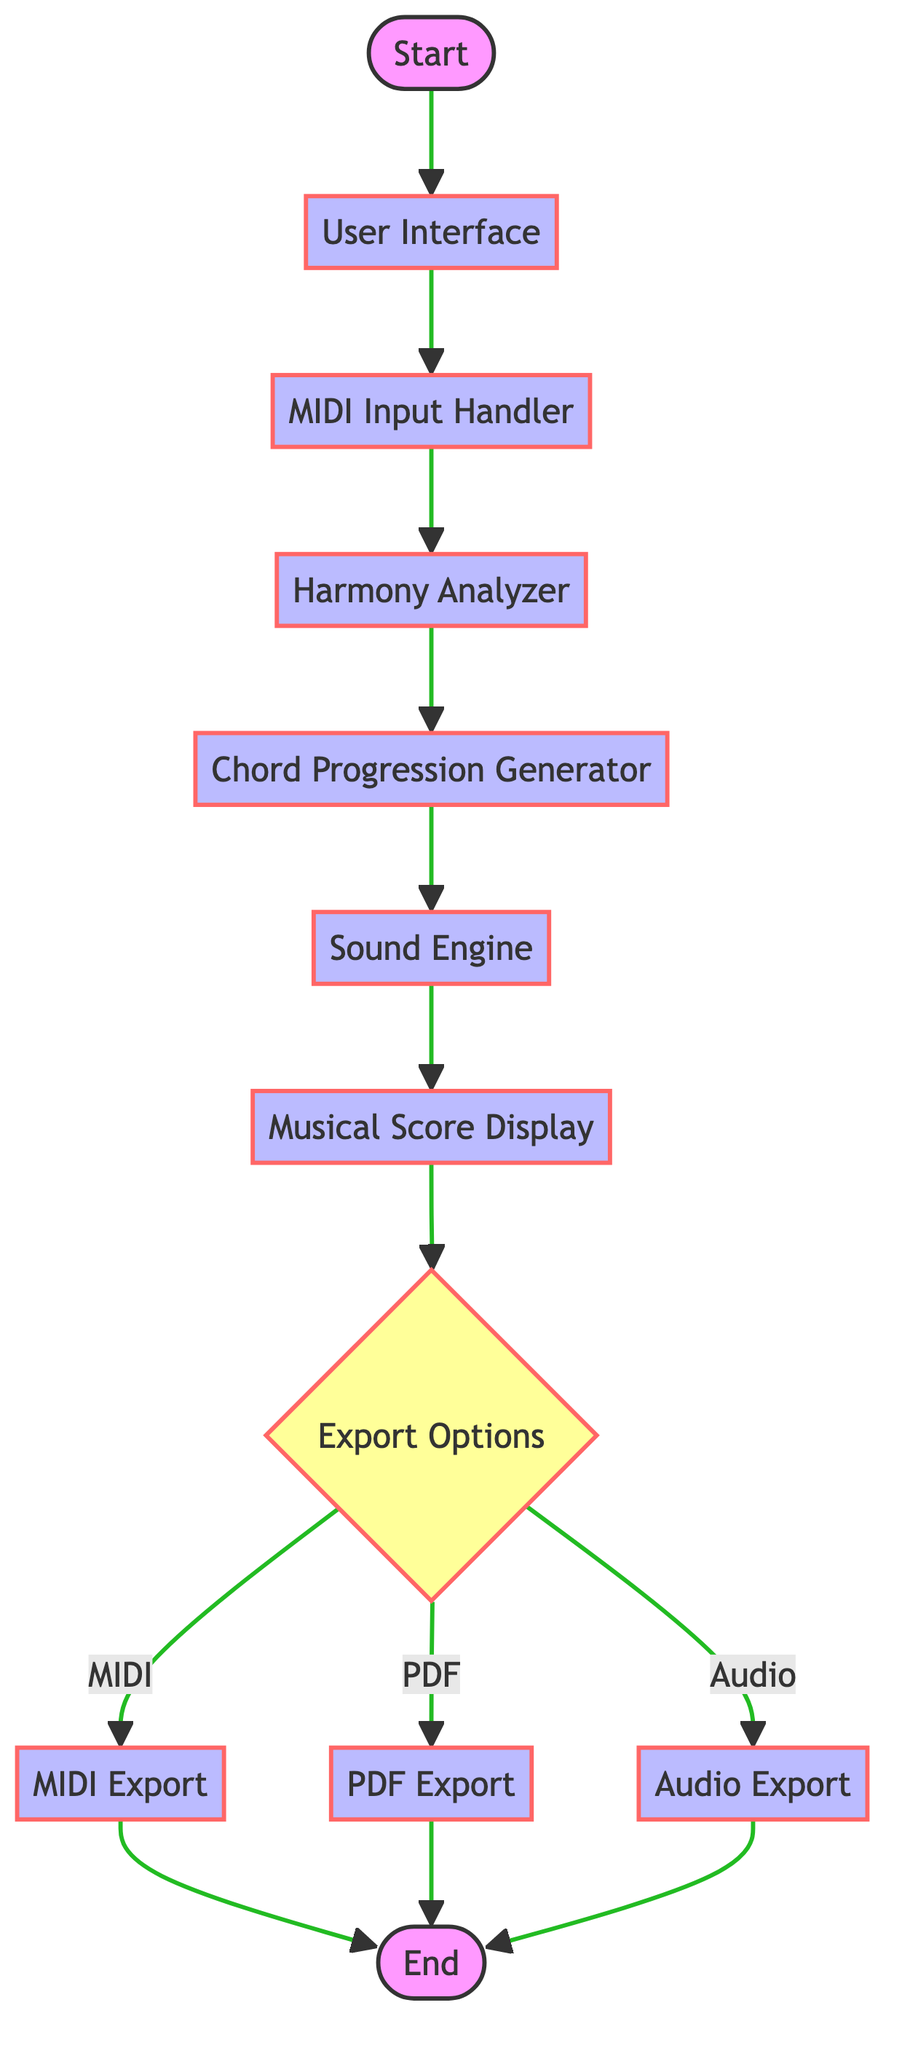What is the first node in the flowchart? The flowchart starts with the "Start" node, which is the initial point in the process.
Answer: Start How many process nodes are there in total? There are seven process nodes in the flowchart: User Interface, MIDI Input Handler, Harmony Analyzer, Chord Progression Generator, Sound Engine, Musical Score Display, and the export options.
Answer: Seven What does the MIDI Input Handler do? The MIDI Input Handler processes and transforms MIDI input from instruments, serving as a necessary step to interact with musical data.
Answer: Process and transform MIDI input Which node follows the Sound Engine? The node that follows the Sound Engine is the Musical Score Display, which visualizes the musical notation for both generated and input music.
Answer: Musical Score Display What are the possible export formats according to the decision node? The Export Options decision node presents three possible export formats: MIDI, PDF, and Audio, giving users flexibility on how to save their compositions.
Answer: MIDI, PDF, Audio What is the purpose of the Harmony Analyzer? The purpose of the Harmony Analyzer is to analyze the melody for its harmonic structure, which is crucial for generating appropriate chord progressions in the next step.
Answer: Analyze melody for harmonic structure Which node results in exporting to an audio file? The Audio Export node results in exporting the composition to an audio file, as indicated by the flow from the decision point after the Musical Score Display.
Answer: Audio Export Which node is connected to both MIDI and PDF export options? The Export Options node is connected to both MIDI Export and PDF Export, allowing the user to choose either format after deciding to export.
Answer: Export Options What is the last node in the flowchart? The last node in the flowchart is the "End" node, signaling the completion of the interactive music composition process.
Answer: End 